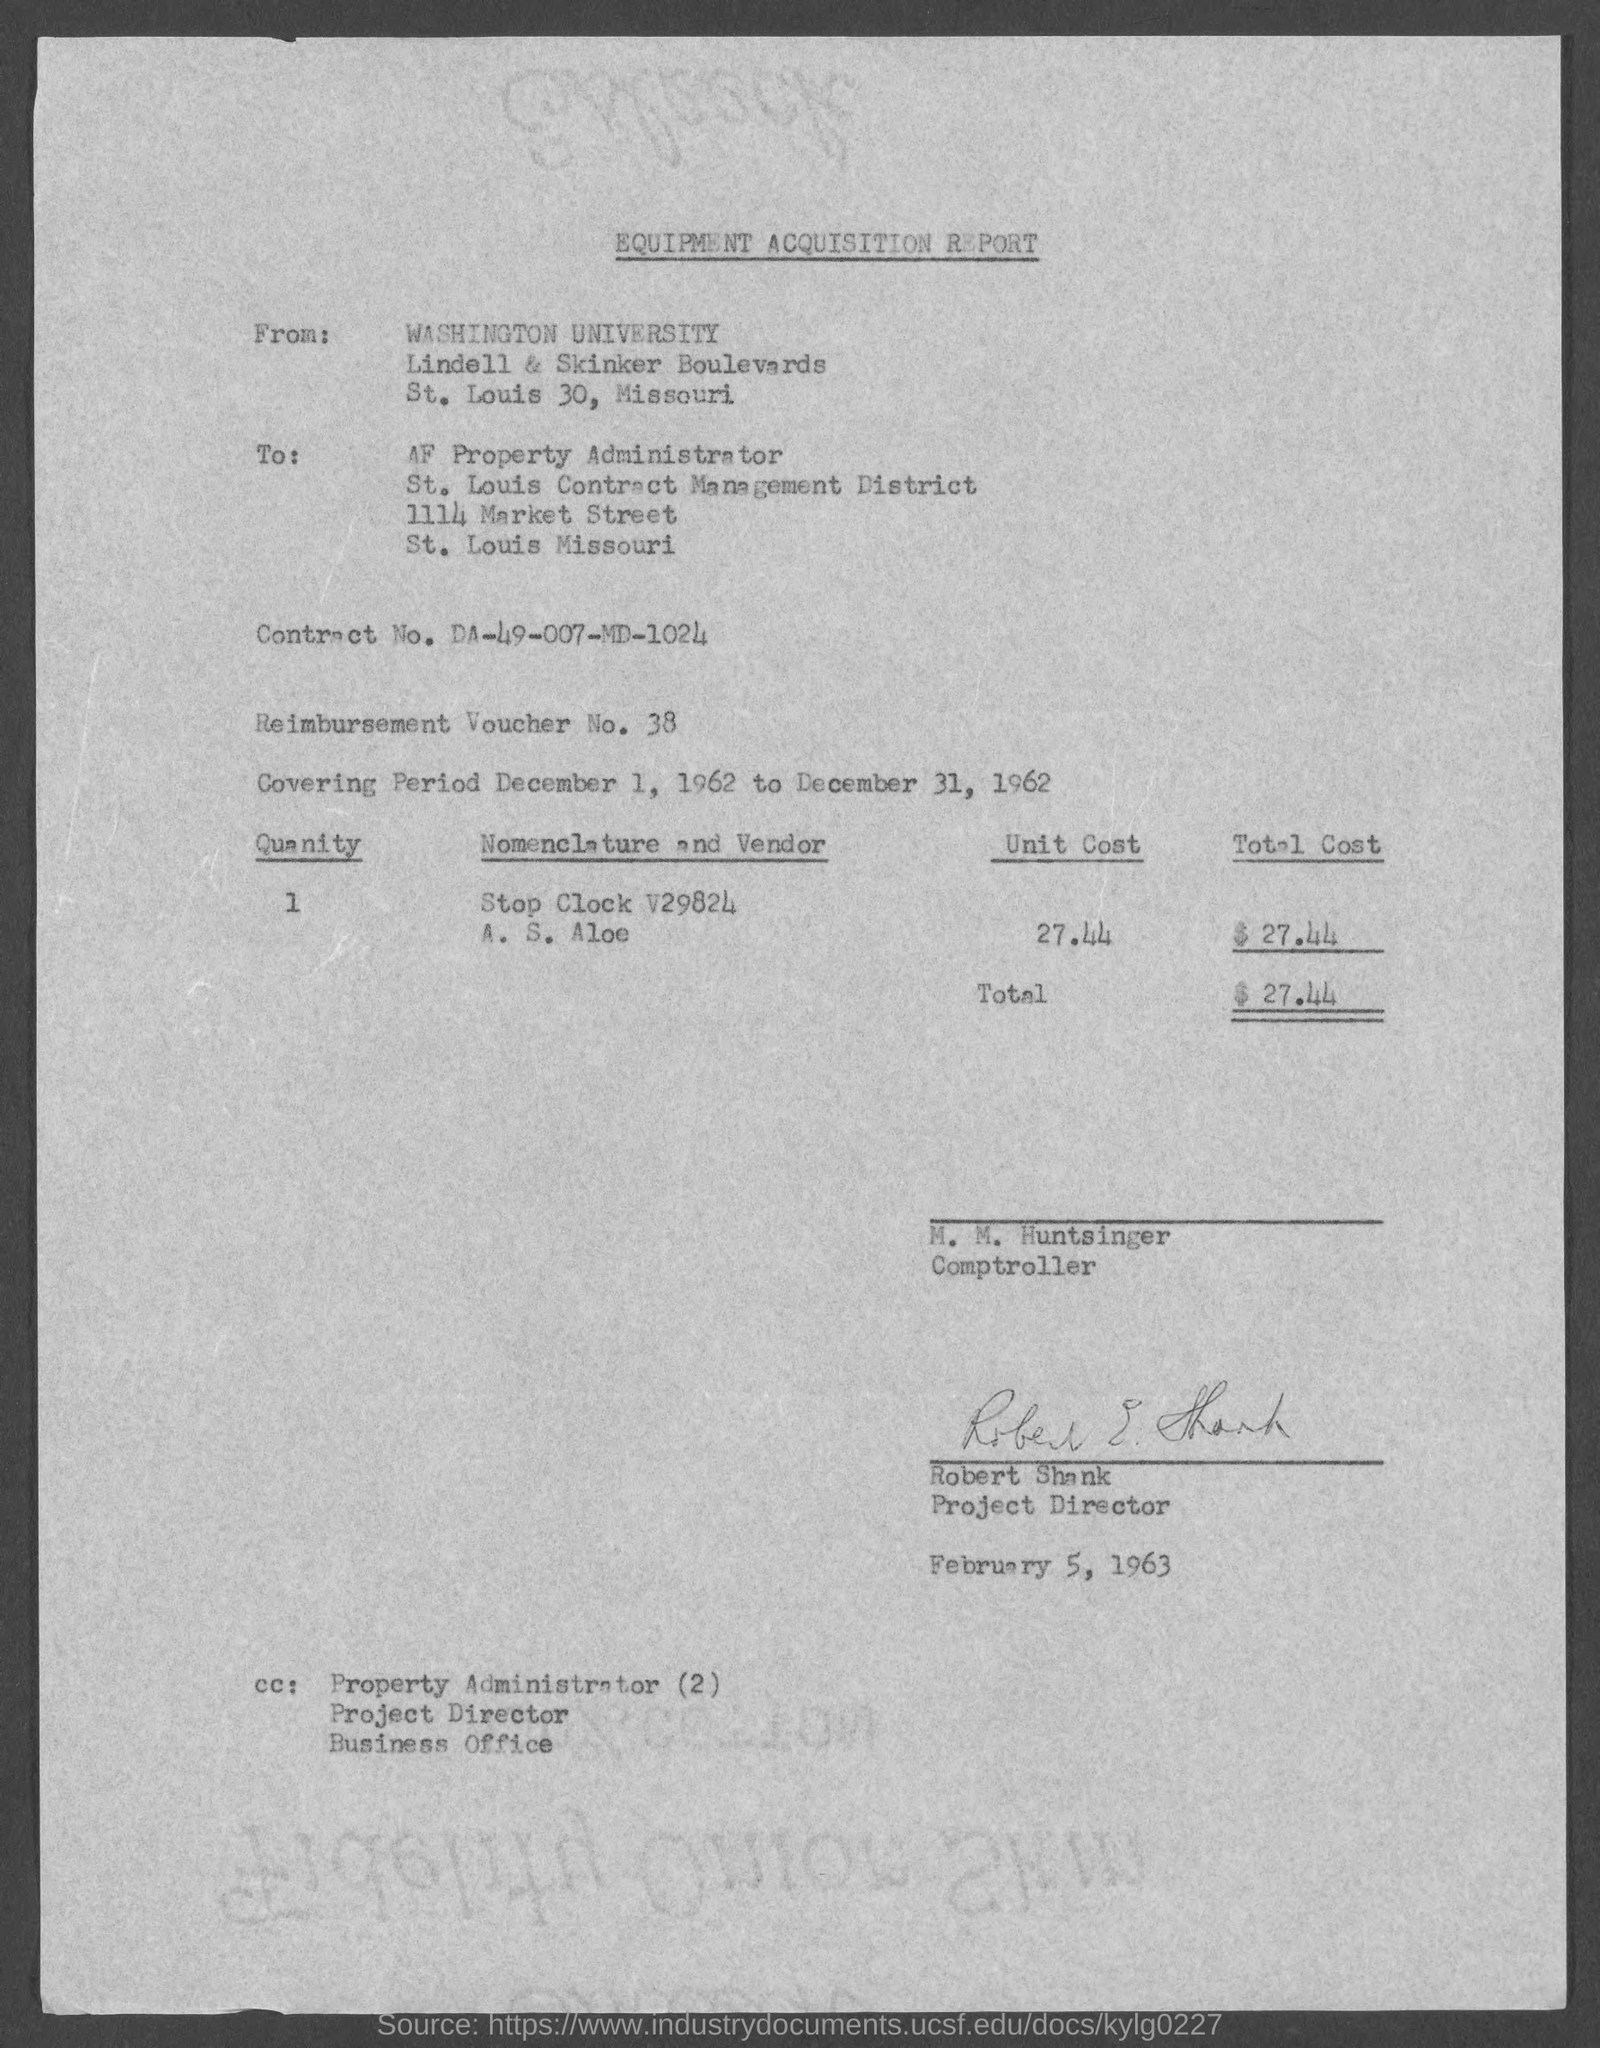Who wrote the report?
Offer a terse response. WASHINGTON UNIVERSITY. What is Contract No.?
Make the answer very short. DA-49-007-MD-1024. What is Reimbursement Voucher No.?
Offer a terse response. 38. What is the currency?
Offer a very short reply. $. 